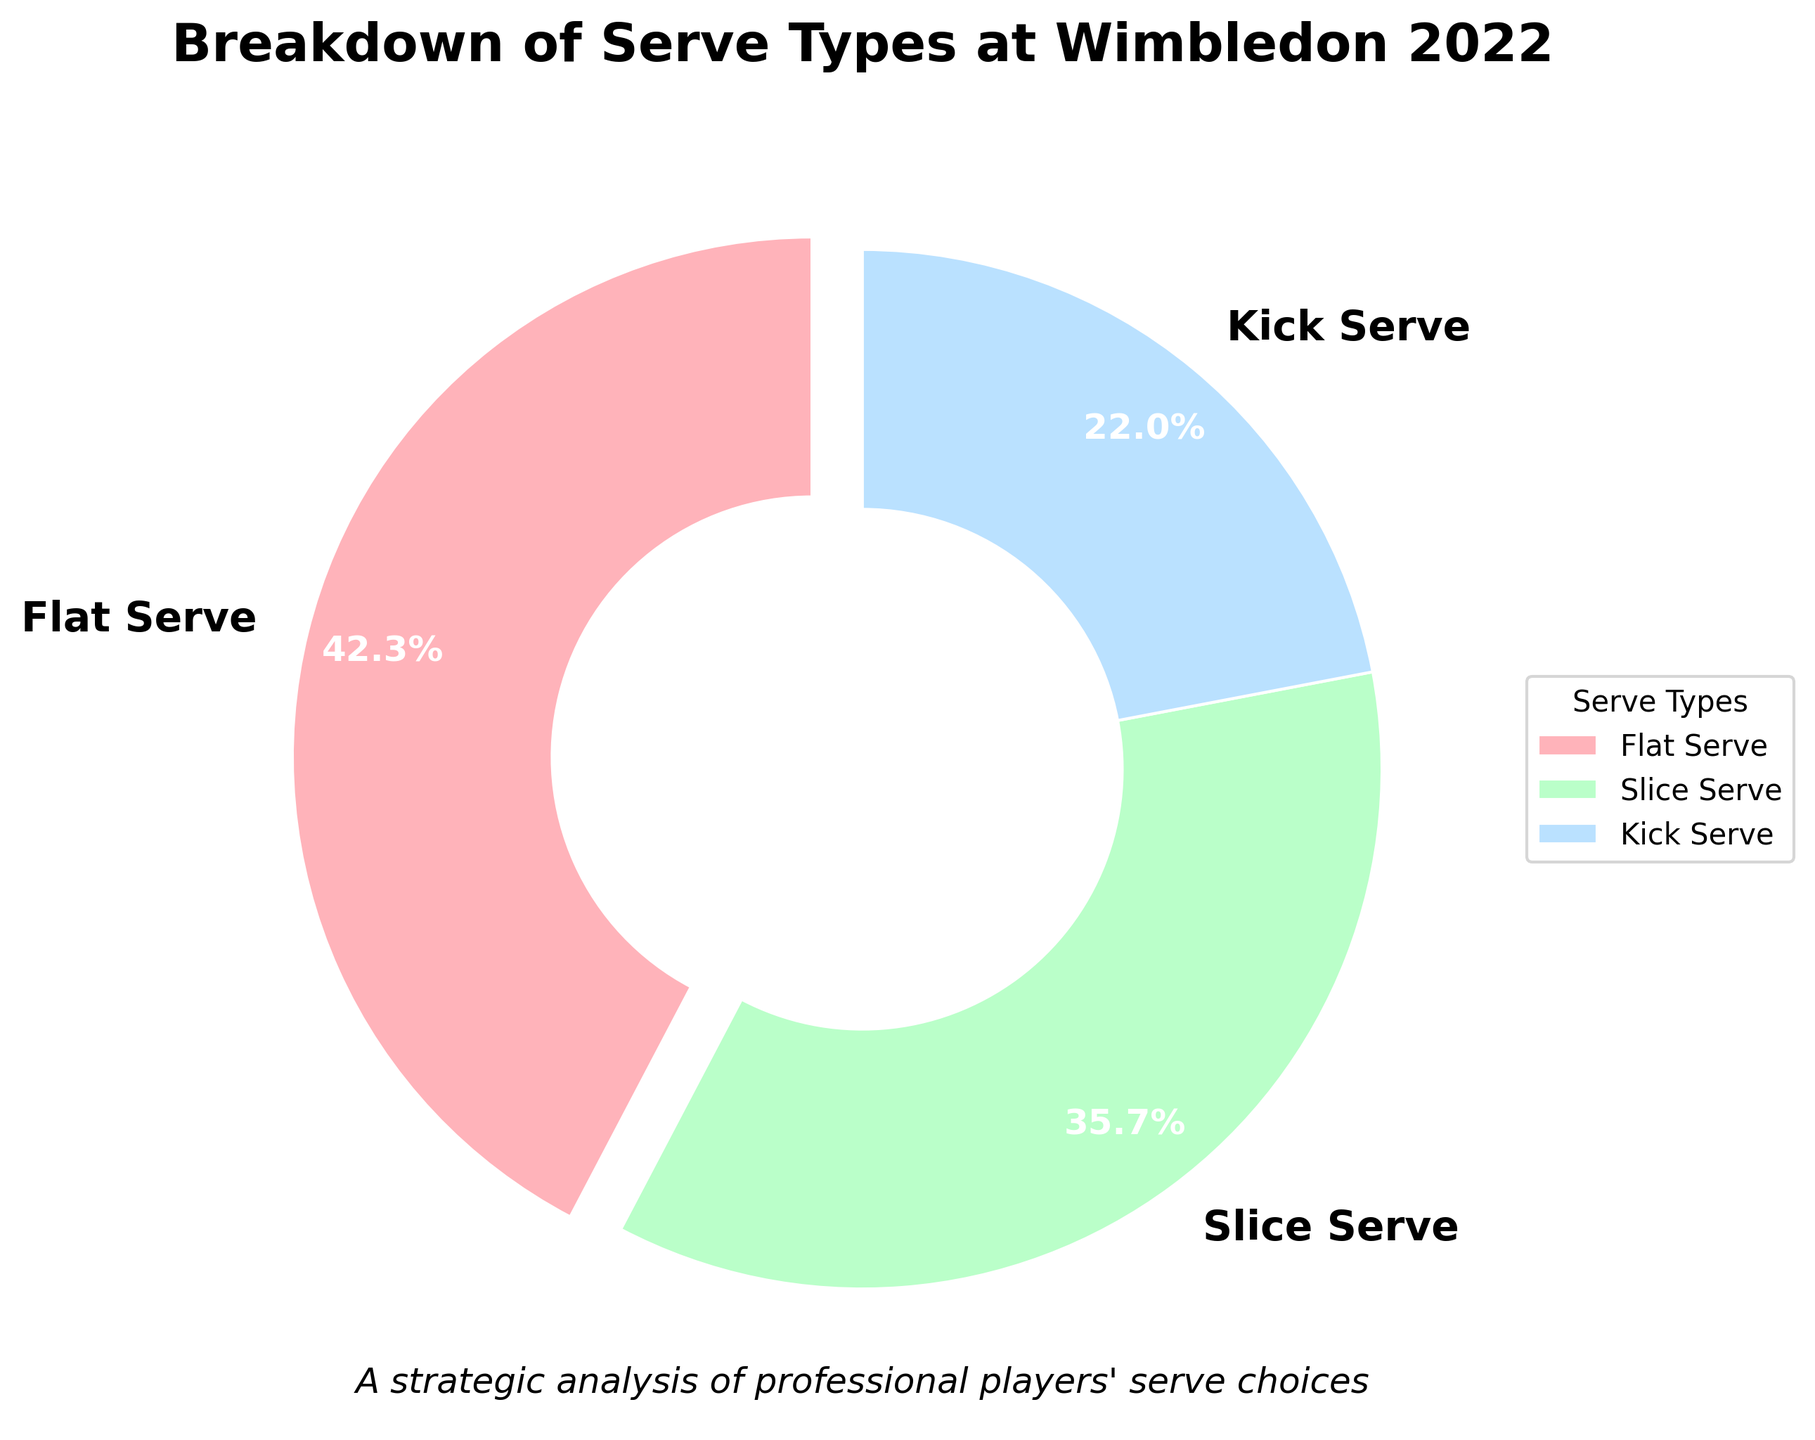What percentage of serves at Wimbledon 2022 were flat serves? The percentage of flat serves is indicated on the pie chart segment labeled "Flat Serve."
Answer: 42.3% How much more popular were flat serves compared to kick serves? To find the difference in popularity between flat and kick serves, subtract the percentage of kick serves from the percentage of flat serves: 42.3% - 22.0% = 20.3%.
Answer: 20.3% Which serve type was the least used during Wimbledon 2022? The least used serve type is determined by the smallest percentage on the pie chart, which is labeled "Kick Serve" at 22.0%.
Answer: Kick Serve If you combine flat and slice serves, what percentage of total serve types do they comprise at Wimbledon 2022? Add the percentages of flat and slice serves: 42.3% + 35.7% = 78.0%.
Answer: 78.0% Do flat serves and slice serves combined represent more than three-quarters of total serves? Sum the percentages of flat and slice serves: 42.3% + 35.7% = 78.0%. Since 78.0% > 75%, they represent more than three-quarters.
Answer: Yes Which serve type is represented by the green color in the pie chart? The green color on the pie chart corresponds to the "Slice Serve" segment, as shown in the legend.
Answer: Slice Serve Rank the serve types from most used to least used based on the percentages. To rank the serve types, list them in descending order based on their percentages: Flat Serve (42.3%), Slice Serve (35.7%), and Kick Serve (22.0%).
Answer: Flat Serve, Slice Serve, Kick Serve Is there a significant gap between the use of flat and slice serves at Wimbledon 2022? The difference in percentage between flat and slice serves is 42.3% - 35.7% = 6.6%. This indicates a noticeable but not huge gap.
Answer: No significant gap By how many percentage points do slice serves exceed kick serves? Subtract the percentage of kick serves from the percentage of slice serves: 35.7% - 22.0% = 13.7%.
Answer: 13.7% What visual element differentiates the flat serve segment from the others? The flat serve segment is visually separated by being slightly pulled out or "exploded" from the rest of the pie chart.
Answer: It's exploded 